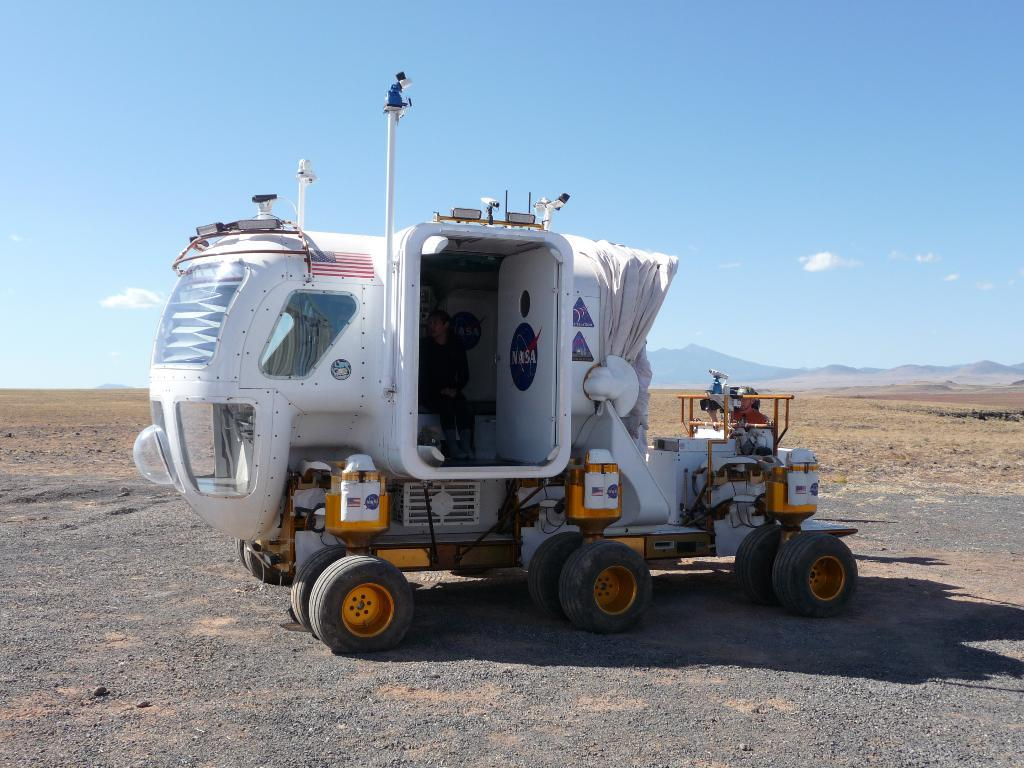What is the main subject of the image? There is a vehicle on the road in the image. Can you describe the person be seen in the image? Yes, there is a person in the image. What type of natural environment is visible in the background of the image? There is grass, mountains, and the sky visible in the background of the image. What time of day does the image appear to be taken? The image appears to be taken during the day. How many sacks are being balanced by the person in the image? There is no person balancing any sacks in the image. What type of table is present in the image? There is no table present in the image. 